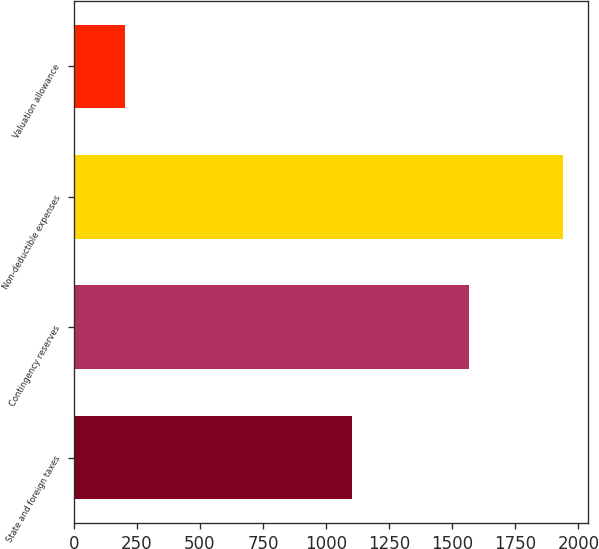Convert chart. <chart><loc_0><loc_0><loc_500><loc_500><bar_chart><fcel>State and foreign taxes<fcel>Contingency reserves<fcel>Non-deductible expenses<fcel>Valuation allowance<nl><fcel>1101<fcel>1566<fcel>1940<fcel>203<nl></chart> 